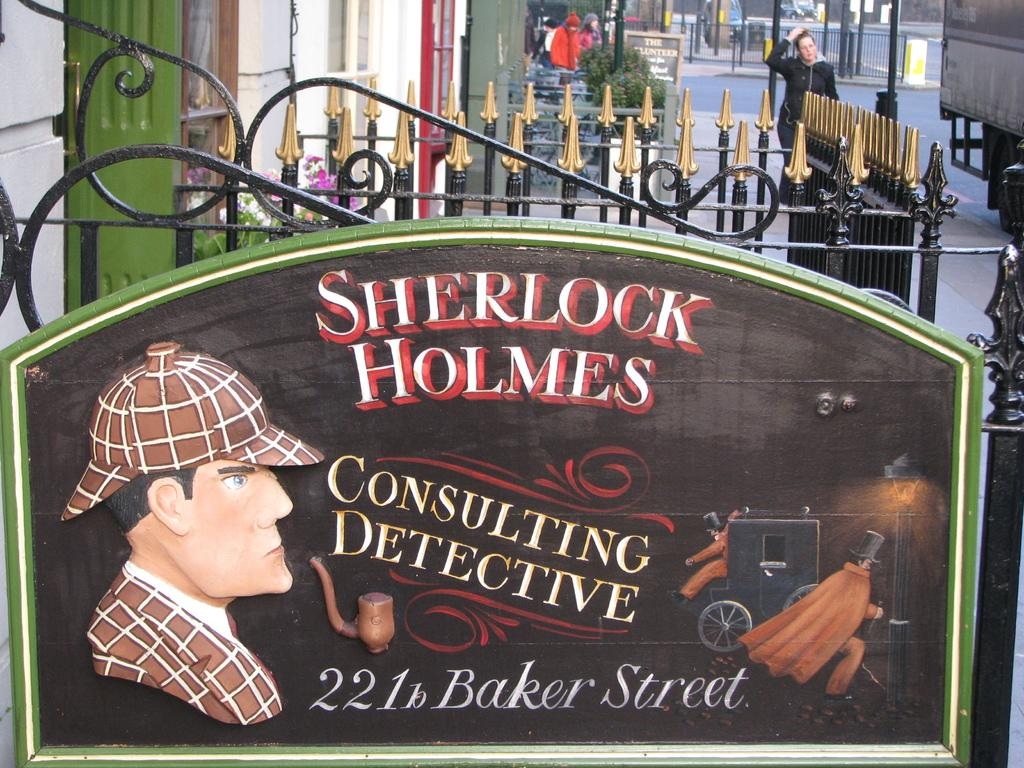What can be seen on the name boards in the image? The content of the name boards cannot be determined from the image. What are the people in the image doing? There is a group of people standing in the image, but their actions cannot be determined. What type of structure is visible in the image? Iron grilles are visible in the image. What is present on the road in the image? There are vehicles on the road in the image. What type of vegetation is in the image? There are plants in the image. What type of treatment is being administered to the plants in the image? There is no indication of any treatment being administered to the plants in the image. What time of day is it in the image, based on the people's activities? The image does not provide enough information to determine the time of day. What hobbies do the people in the image enjoy? The image does not provide enough information to determine the hobbies of the people in the image. 